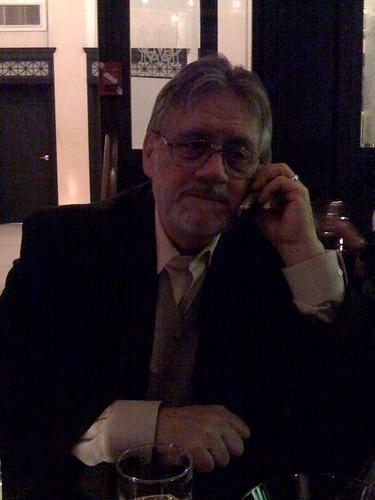How many phones are in the man's hands?
Give a very brief answer. 1. 